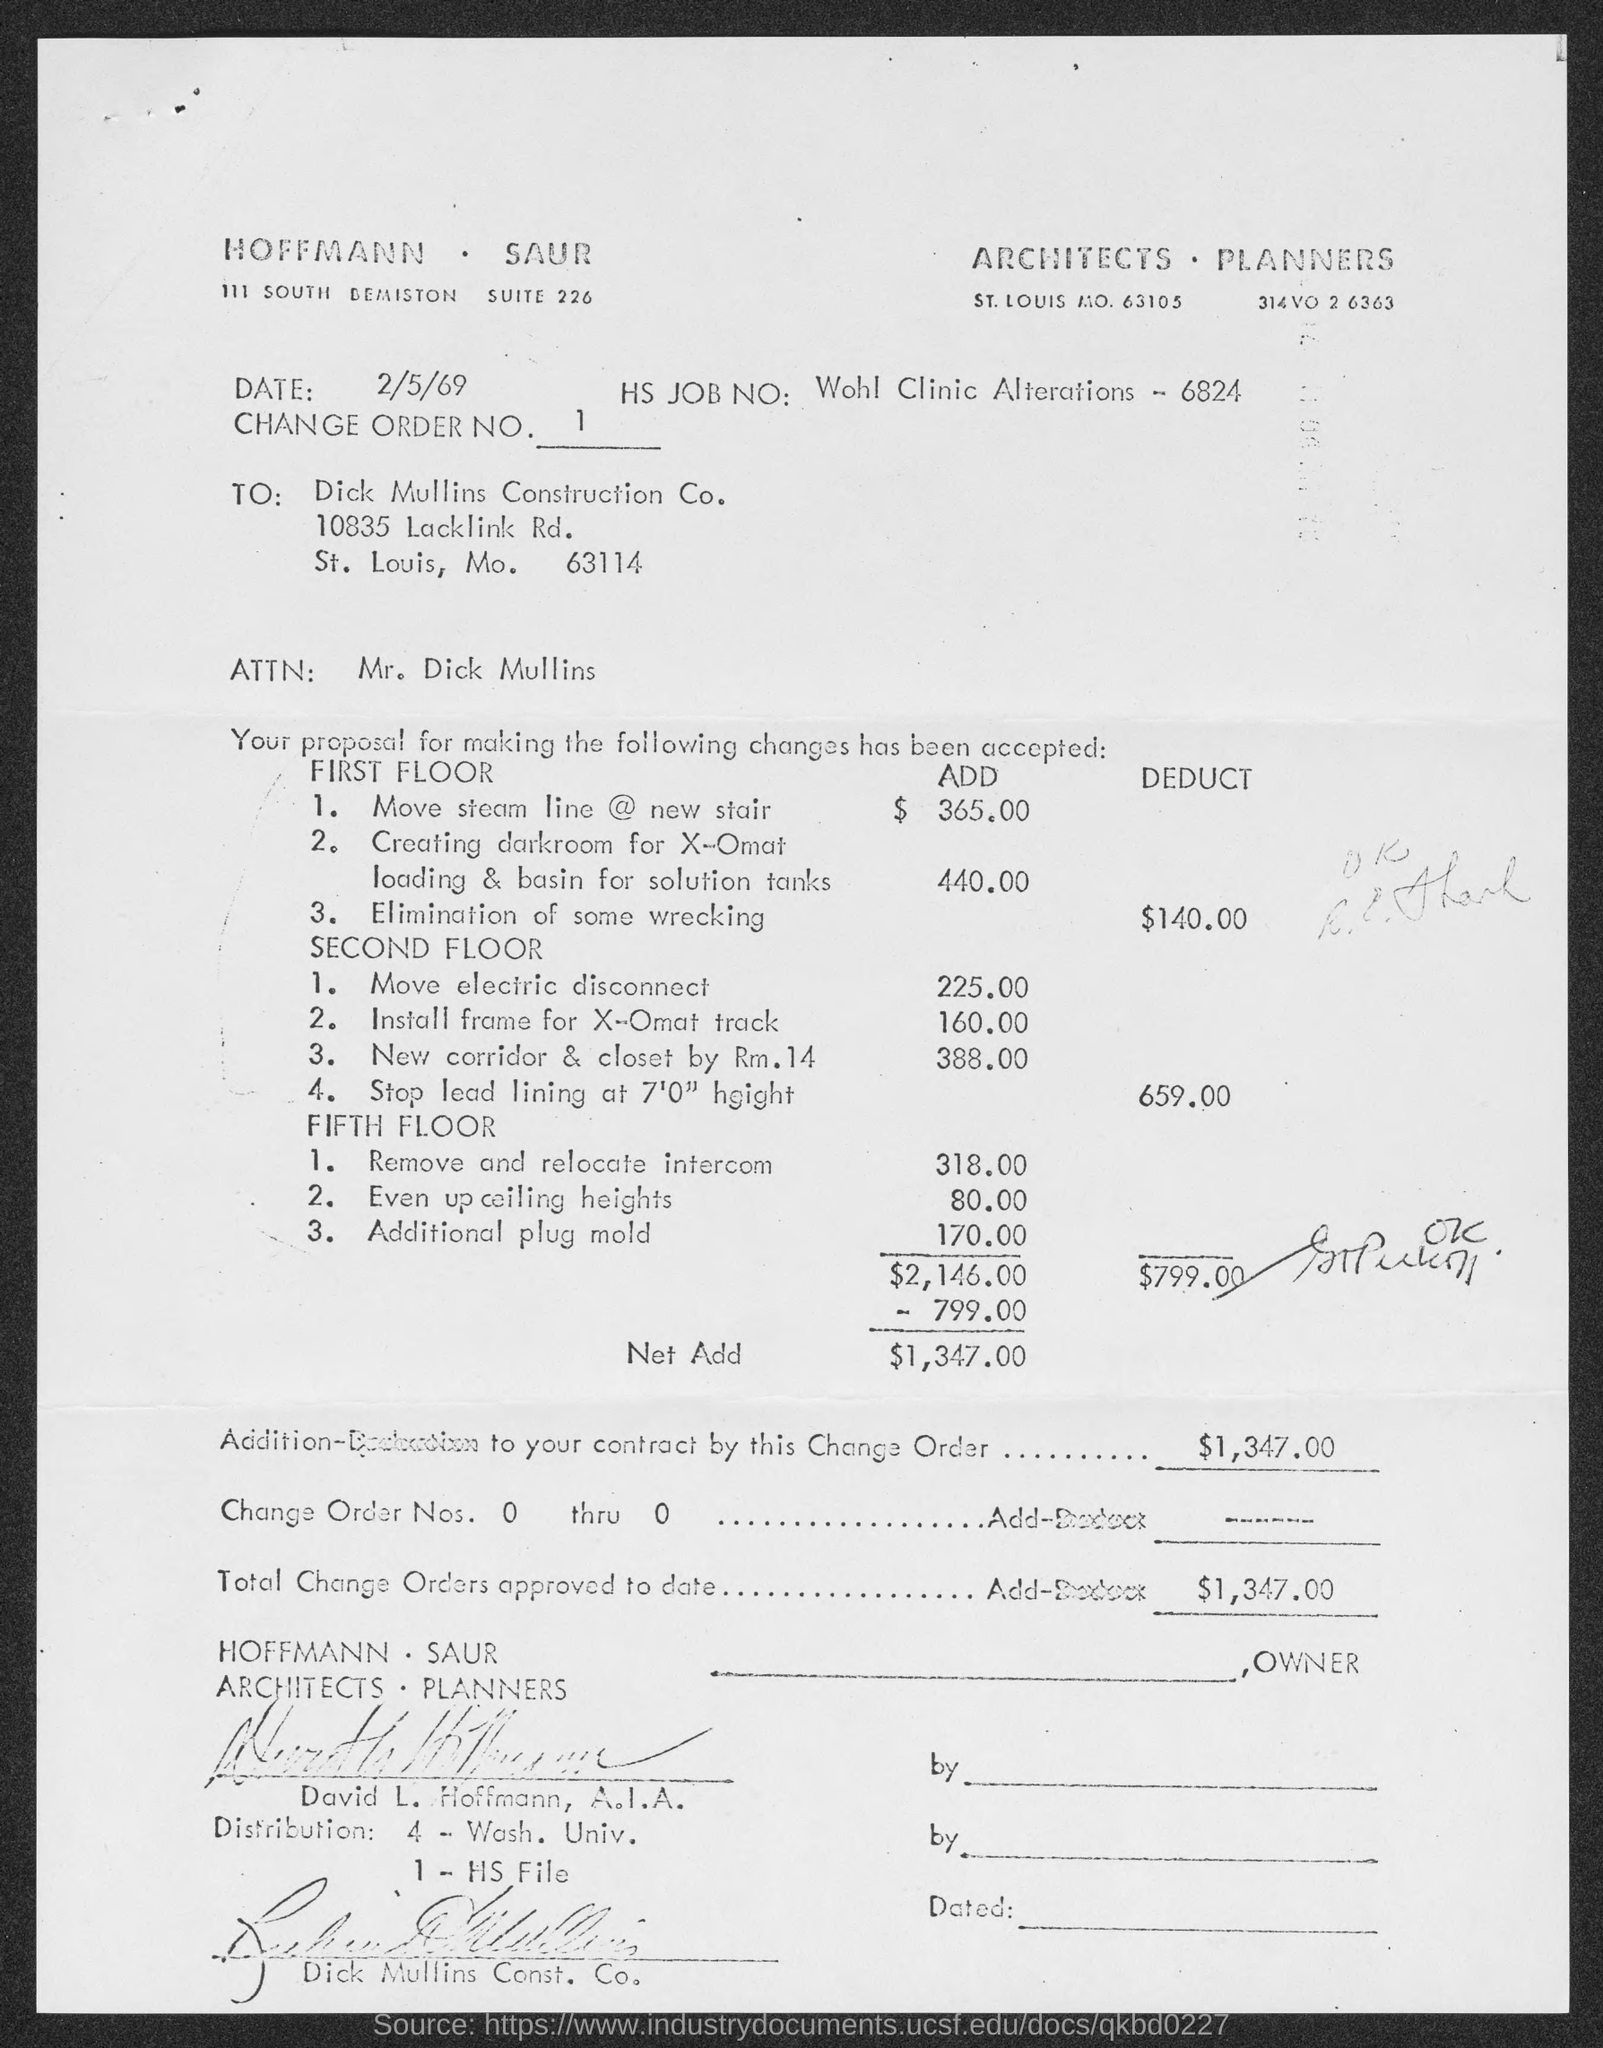Give some essential details in this illustration. What is the Change order number? It is a series of numbers that range from 1 to... The memorandum is dated on February 5, 1969. 